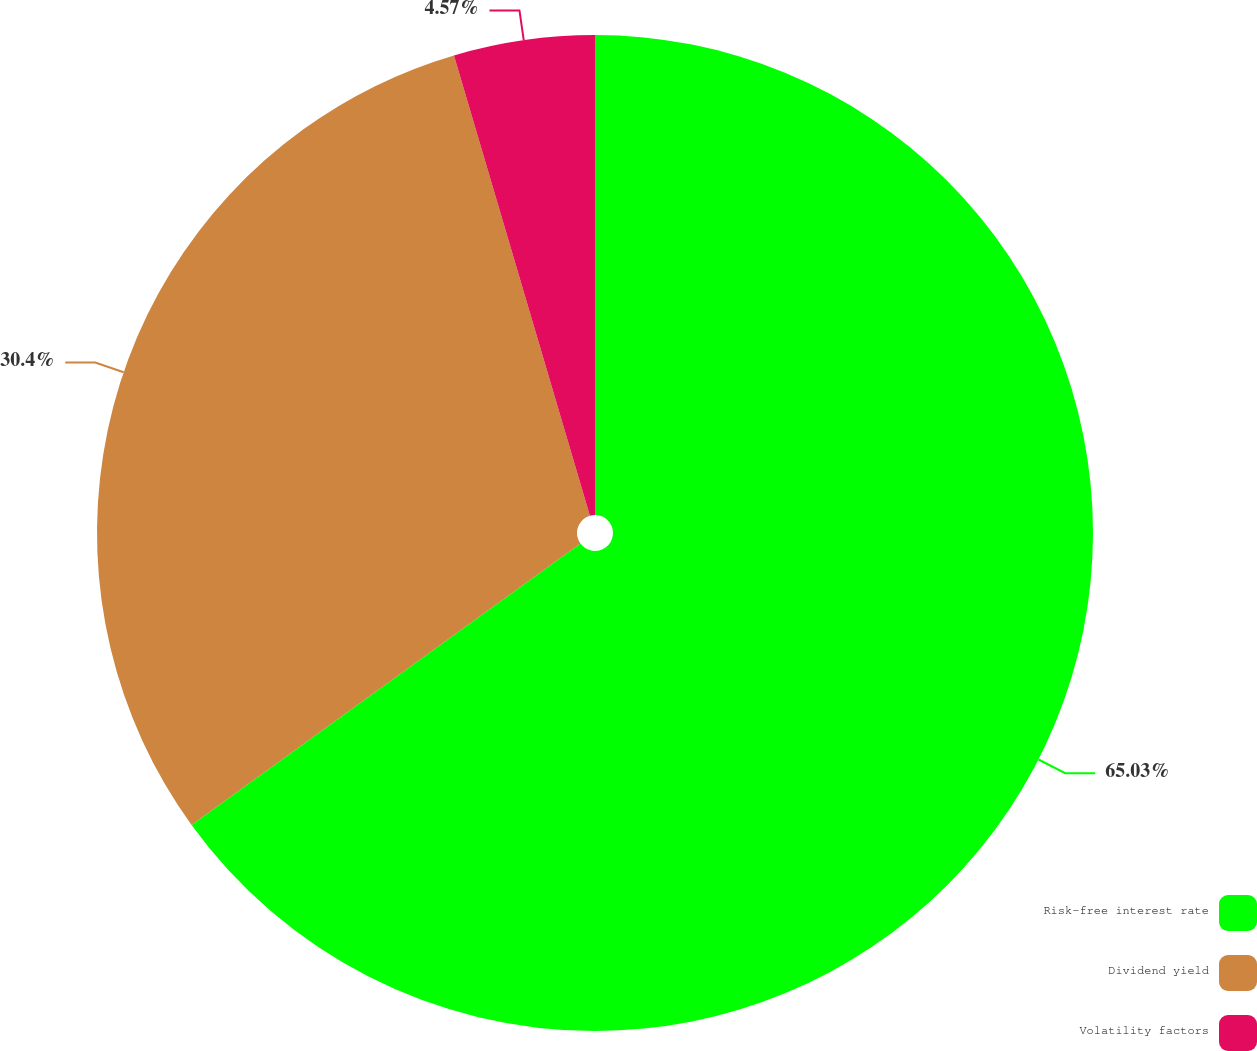Convert chart to OTSL. <chart><loc_0><loc_0><loc_500><loc_500><pie_chart><fcel>Risk-free interest rate<fcel>Dividend yield<fcel>Volatility factors<nl><fcel>65.03%<fcel>30.4%<fcel>4.57%<nl></chart> 